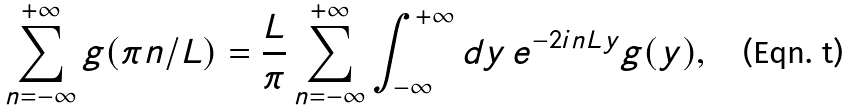Convert formula to latex. <formula><loc_0><loc_0><loc_500><loc_500>\sum _ { n = - \infty } ^ { + \infty } g ( \pi n / L ) = \frac { L } { \pi } \sum _ { n = - \infty } ^ { + \infty } \int _ { - \infty } ^ { + \infty } d y \, e ^ { - 2 i n L y } g ( y ) ,</formula> 